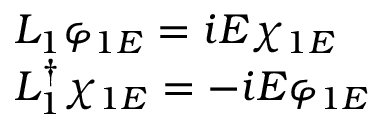Convert formula to latex. <formula><loc_0><loc_0><loc_500><loc_500>\begin{array} { l } { { L _ { 1 } \varphi _ { 1 E } = i E \chi _ { 1 E } } } \\ { { L _ { 1 } ^ { \dag } \chi _ { 1 E } = - i E \varphi _ { 1 E } } } \end{array}</formula> 